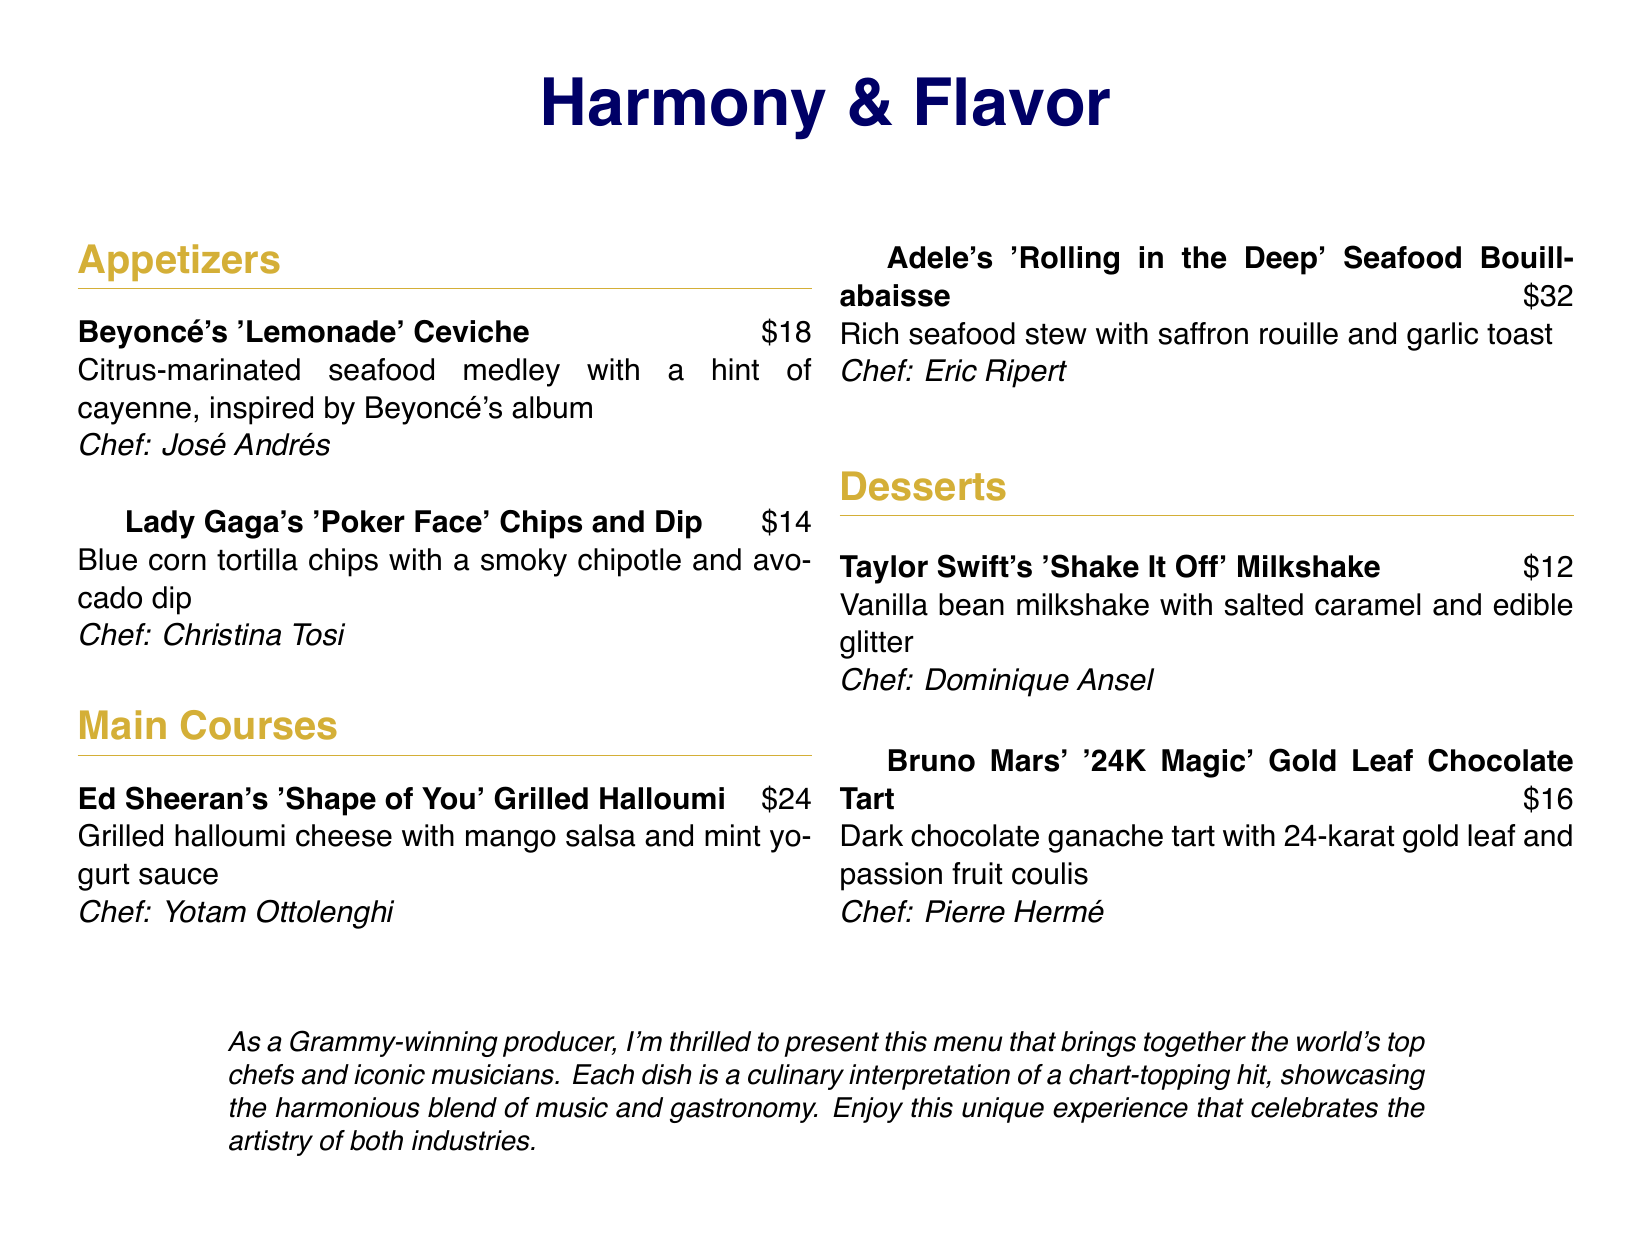what is the title of the menu? The title of the menu is prominently displayed at the top of the document.
Answer: Harmony & Flavor who is the chef for Beyoncé's dish? The chef for Beyoncé's 'Lemonade' Ceviche is mentioned alongside the dish.
Answer: José Andrés what is the price of the dessert by Taylor Swift? The price is listed right beside the dessert name in the menu.
Answer: $12 how many main courses are listed in the menu? The count can be determined by reviewing the main course section of the menu.
Answer: 2 which dish is inspired by Lady Gaga? The dish name is provided in the appetizers section of the menu.
Answer: Poker Face Chips and Dip what type of sauce accompanies Ed Sheeran's dish? The accompanying sauce is described in the main course item details.
Answer: Mint yogurt sauce who created the Gold Leaf Chocolate Tart? The chef's name is provided with the description of the dessert in the menu.
Answer: Pierre Hermé what is the base flavor of Taylor Swift's milkshake? The milkshake description in the menu indicates its primary flavor.
Answer: Vanilla bean what common theme do the dishes share? The dishes are connected through their inspirations as presented in the document.
Answer: Hit songs 